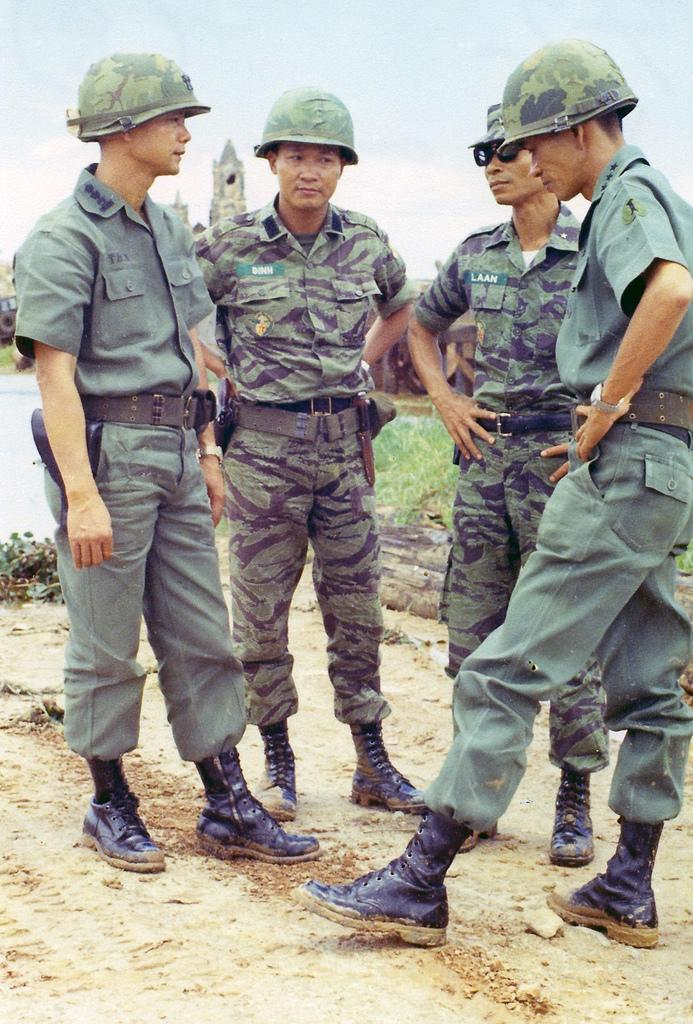How many people are in the image? There is a group of people standing in the image. What can be seen in the background of the image? There is a building in the background of the image. What else is visible in the image besides the people and the building? There are vehicles in the image. What is visible at the top of the image? The sky is visible at the top of the image. What type of surface is present at the bottom of the image? Grass is present at the bottom of the image. What type of religious ceremony is taking place in the image? There is no indication of a religious ceremony in the image; it simply shows a group of people standing with a building, vehicles, sky, and grass visible. How many beds are visible in the image? There are no beds present in the image. 